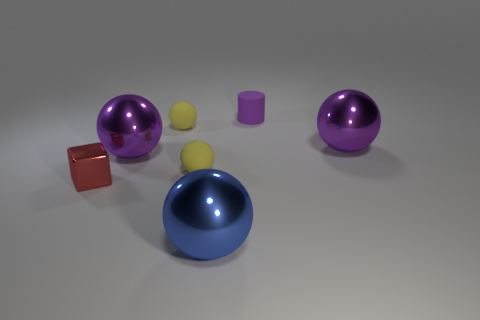Subtract all gray blocks. How many yellow spheres are left? 2 Subtract all blue balls. How many balls are left? 4 Subtract all blue balls. How many balls are left? 4 Subtract all gray balls. Subtract all red blocks. How many balls are left? 5 Add 1 metallic blocks. How many objects exist? 8 Subtract all blocks. How many objects are left? 6 Subtract 2 yellow balls. How many objects are left? 5 Subtract all tiny red shiny cubes. Subtract all large blue metal balls. How many objects are left? 5 Add 1 tiny purple matte things. How many tiny purple matte things are left? 2 Add 4 small purple rubber cylinders. How many small purple rubber cylinders exist? 5 